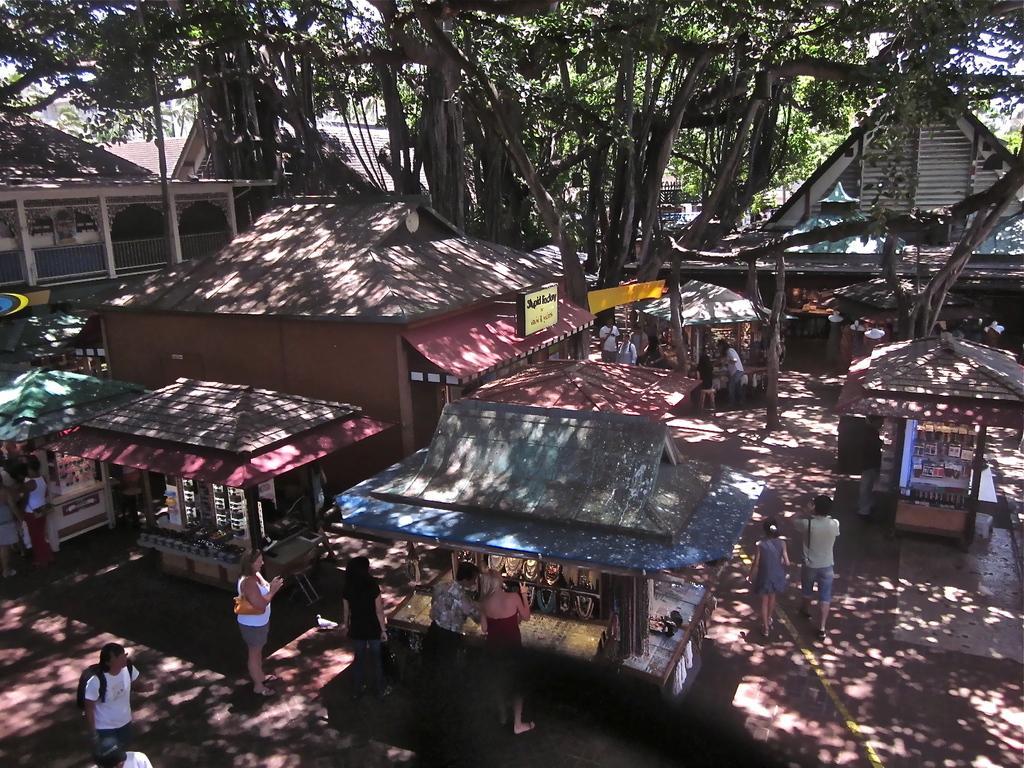In one or two sentences, can you explain what this image depicts? In this image there are ships and there are people and there is a tree. 